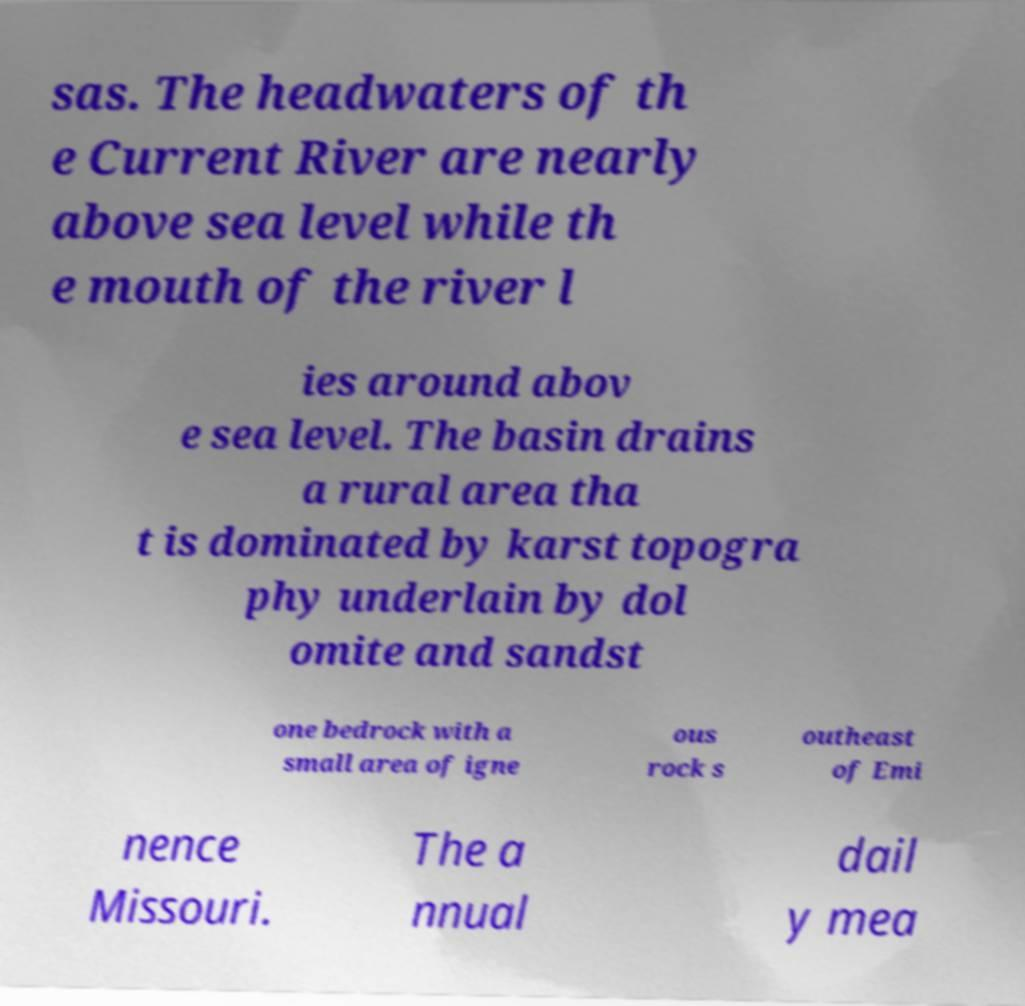There's text embedded in this image that I need extracted. Can you transcribe it verbatim? sas. The headwaters of th e Current River are nearly above sea level while th e mouth of the river l ies around abov e sea level. The basin drains a rural area tha t is dominated by karst topogra phy underlain by dol omite and sandst one bedrock with a small area of igne ous rock s outheast of Emi nence Missouri. The a nnual dail y mea 